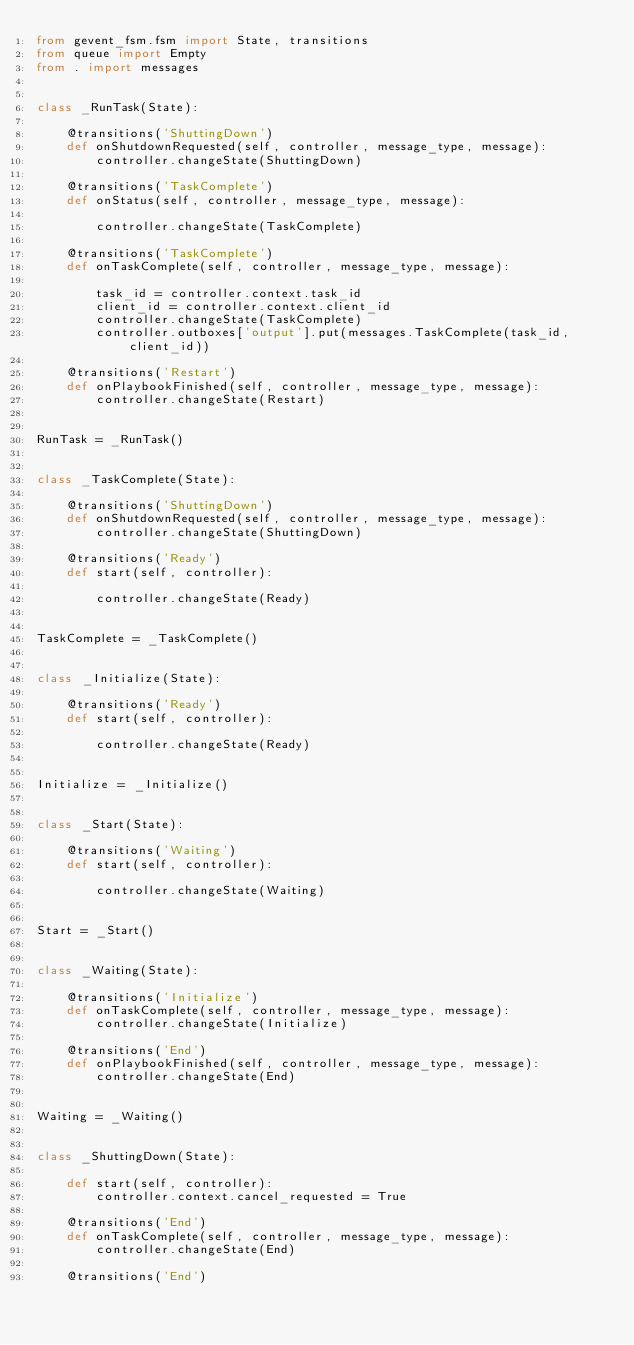Convert code to text. <code><loc_0><loc_0><loc_500><loc_500><_Python_>from gevent_fsm.fsm import State, transitions
from queue import Empty
from . import messages


class _RunTask(State):

    @transitions('ShuttingDown')
    def onShutdownRequested(self, controller, message_type, message):
        controller.changeState(ShuttingDown)

    @transitions('TaskComplete')
    def onStatus(self, controller, message_type, message):

        controller.changeState(TaskComplete)

    @transitions('TaskComplete')
    def onTaskComplete(self, controller, message_type, message):

        task_id = controller.context.task_id
        client_id = controller.context.client_id
        controller.changeState(TaskComplete)
        controller.outboxes['output'].put(messages.TaskComplete(task_id, client_id))

    @transitions('Restart')
    def onPlaybookFinished(self, controller, message_type, message):
        controller.changeState(Restart)


RunTask = _RunTask()


class _TaskComplete(State):

    @transitions('ShuttingDown')
    def onShutdownRequested(self, controller, message_type, message):
        controller.changeState(ShuttingDown)

    @transitions('Ready')
    def start(self, controller):

        controller.changeState(Ready)


TaskComplete = _TaskComplete()


class _Initialize(State):

    @transitions('Ready')
    def start(self, controller):

        controller.changeState(Ready)


Initialize = _Initialize()


class _Start(State):

    @transitions('Waiting')
    def start(self, controller):

        controller.changeState(Waiting)


Start = _Start()


class _Waiting(State):

    @transitions('Initialize')
    def onTaskComplete(self, controller, message_type, message):
        controller.changeState(Initialize)

    @transitions('End')
    def onPlaybookFinished(self, controller, message_type, message):
        controller.changeState(End)


Waiting = _Waiting()


class _ShuttingDown(State):

    def start(self, controller):
        controller.context.cancel_requested = True

    @transitions('End')
    def onTaskComplete(self, controller, message_type, message):
        controller.changeState(End)

    @transitions('End')</code> 